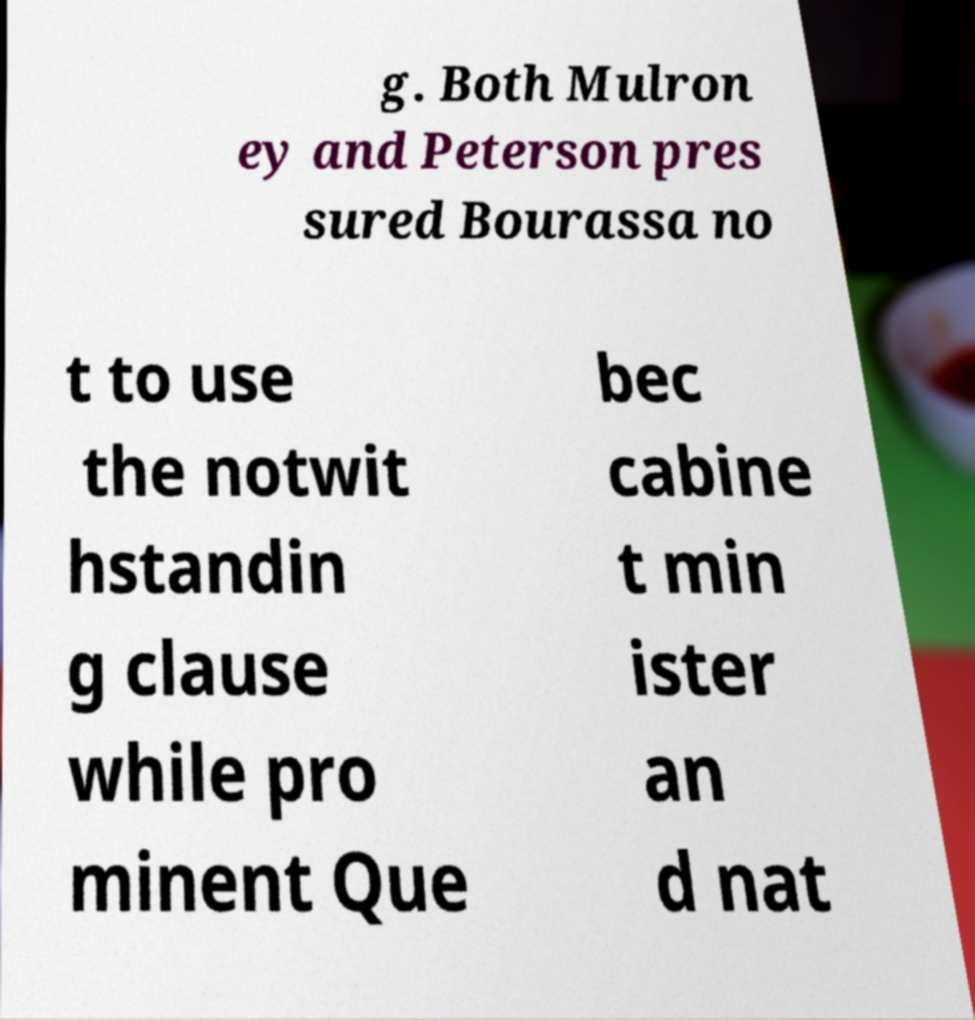Could you assist in decoding the text presented in this image and type it out clearly? g. Both Mulron ey and Peterson pres sured Bourassa no t to use the notwit hstandin g clause while pro minent Que bec cabine t min ister an d nat 